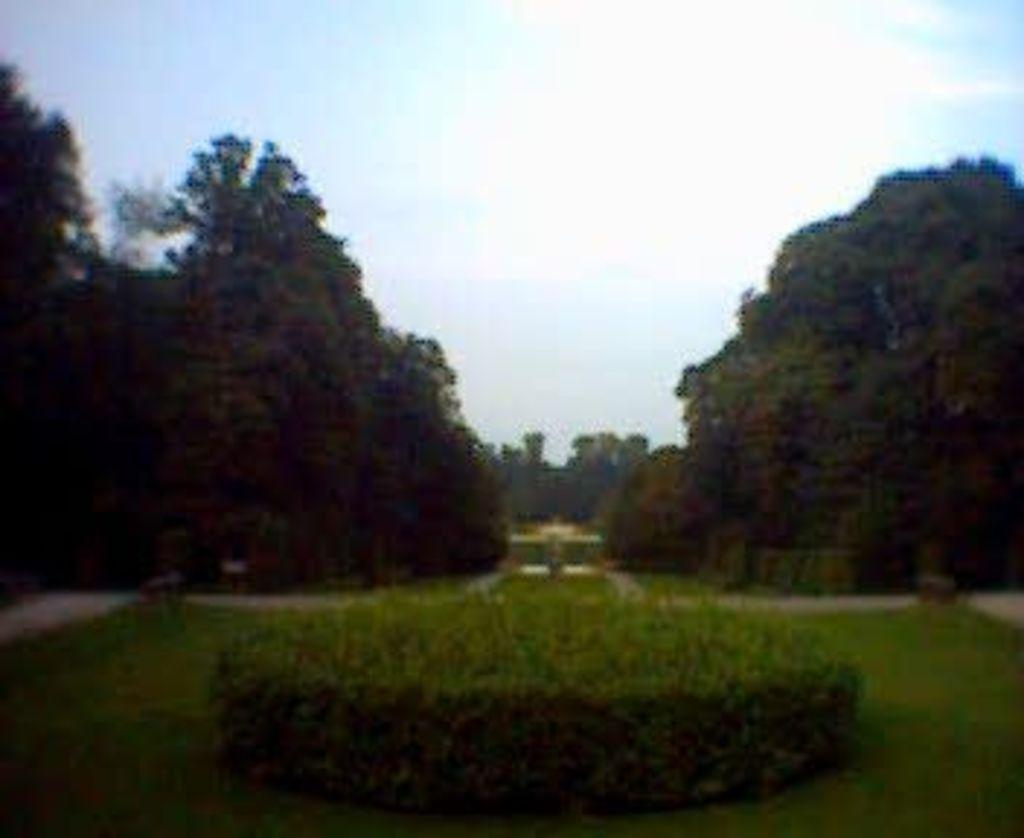What is the overall quality of the image? The image appears to be blurred. What type of vegetation can be seen in the image? There are plants, grass, and trees in the image. What part of the natural environment is visible in the image? The sky is visible in the image. What type of market can be seen in the image? There is no market present in the image; it features plants, grass, trees, and a blurred sky. What song is being sung by the plants in the image? Plants do not have the ability to sing songs, and there is no indication of any song being sung in the image. 